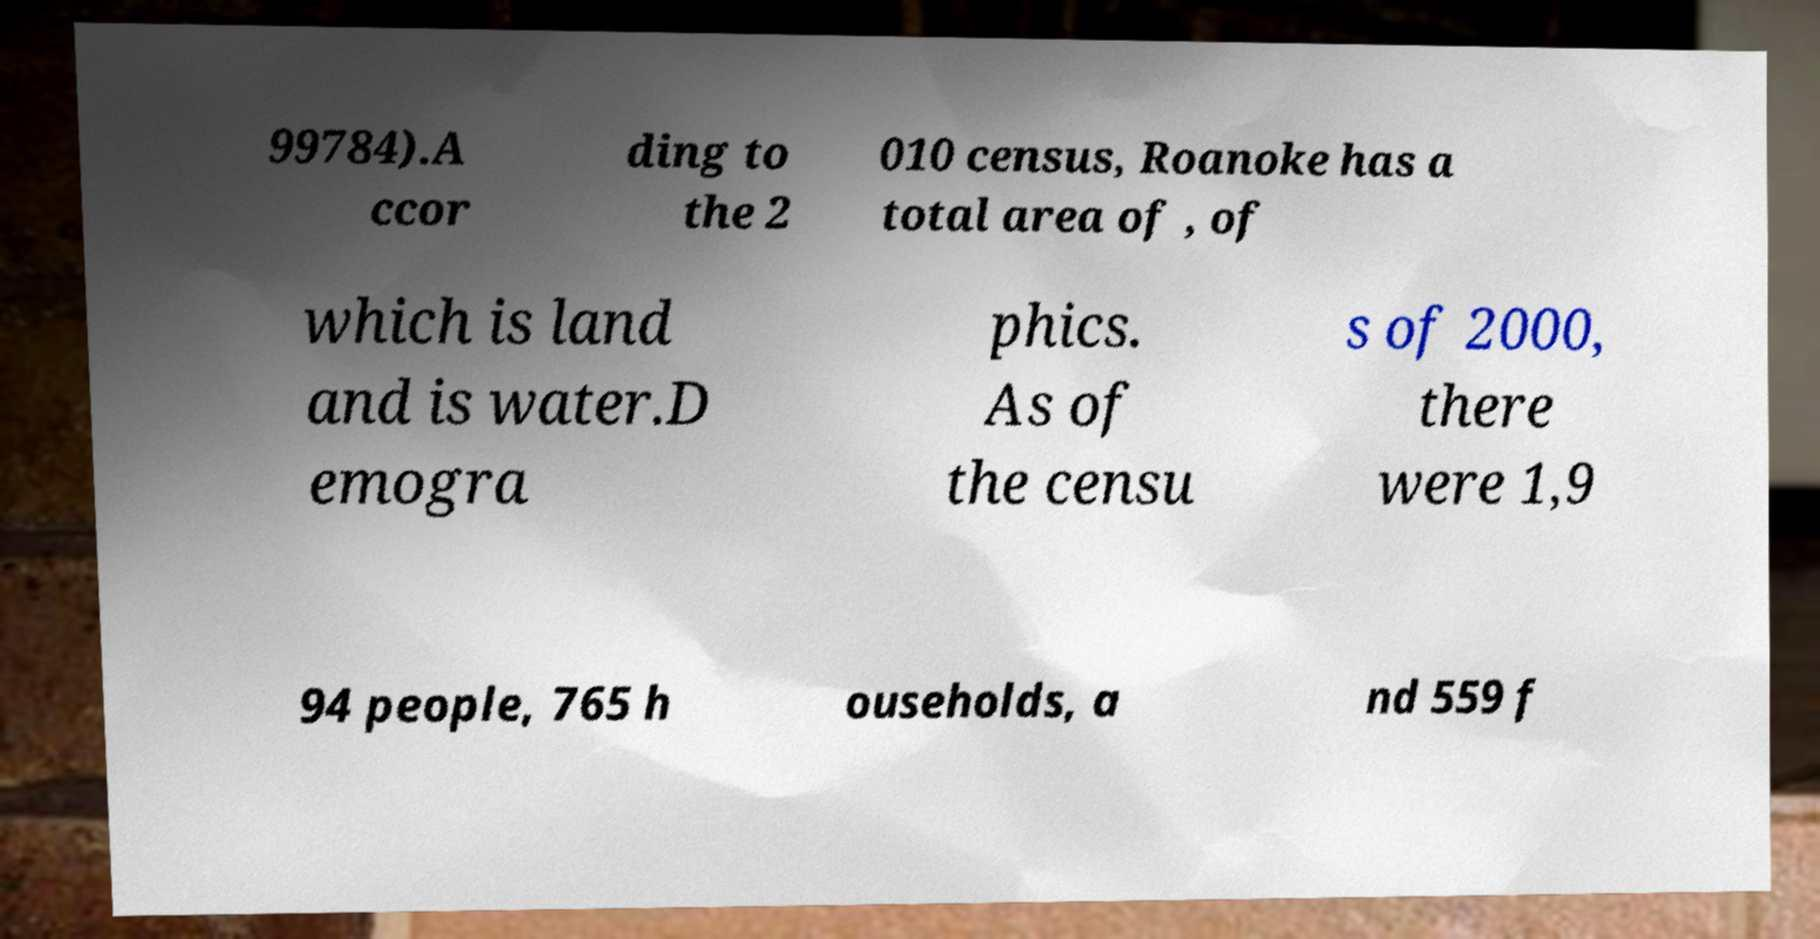Can you accurately transcribe the text from the provided image for me? 99784).A ccor ding to the 2 010 census, Roanoke has a total area of , of which is land and is water.D emogra phics. As of the censu s of 2000, there were 1,9 94 people, 765 h ouseholds, a nd 559 f 